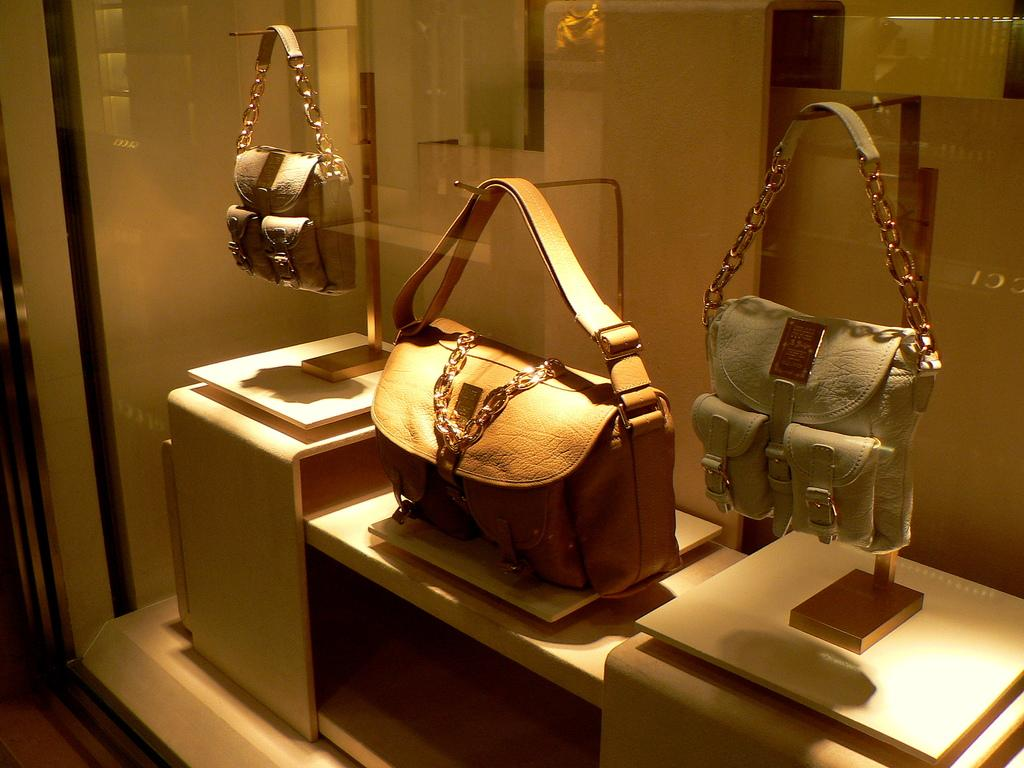How many leather handbags are visible in the image? There are three leather handbags in the image. Where are the handbags located in the image? The handbags are placed inside a glass mirror. What type of noise can be heard coming from the handbags in the image? There is no noise coming from the handbags in the image, as they are inanimate objects. 